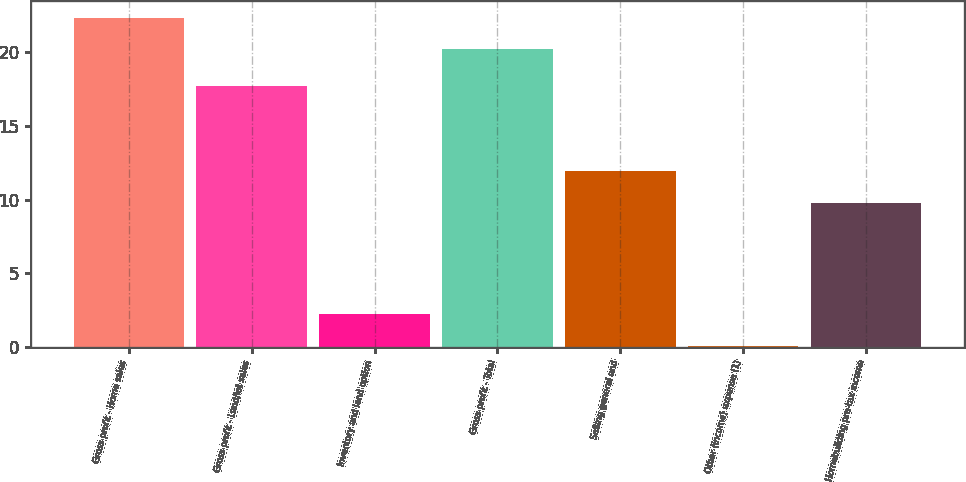Convert chart to OTSL. <chart><loc_0><loc_0><loc_500><loc_500><bar_chart><fcel>Gross profit - Home sales<fcel>Gross profit - Land/lot sales<fcel>Inventory and land option<fcel>Gross profit - Total<fcel>Selling general and<fcel>Other (income) expense (1)<fcel>Homebuilding pre-tax income<nl><fcel>22.32<fcel>17.7<fcel>2.22<fcel>20.2<fcel>11.92<fcel>0.1<fcel>9.8<nl></chart> 